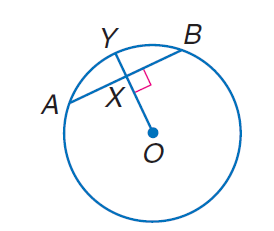Answer the mathemtical geometry problem and directly provide the correct option letter.
Question: Circle O has a radius of 10, A B = 10 and m \overrightarrow A B = 60. Find m \widehat A Y.
Choices: A: 10 B: 30 C: 60 D: 90 B 